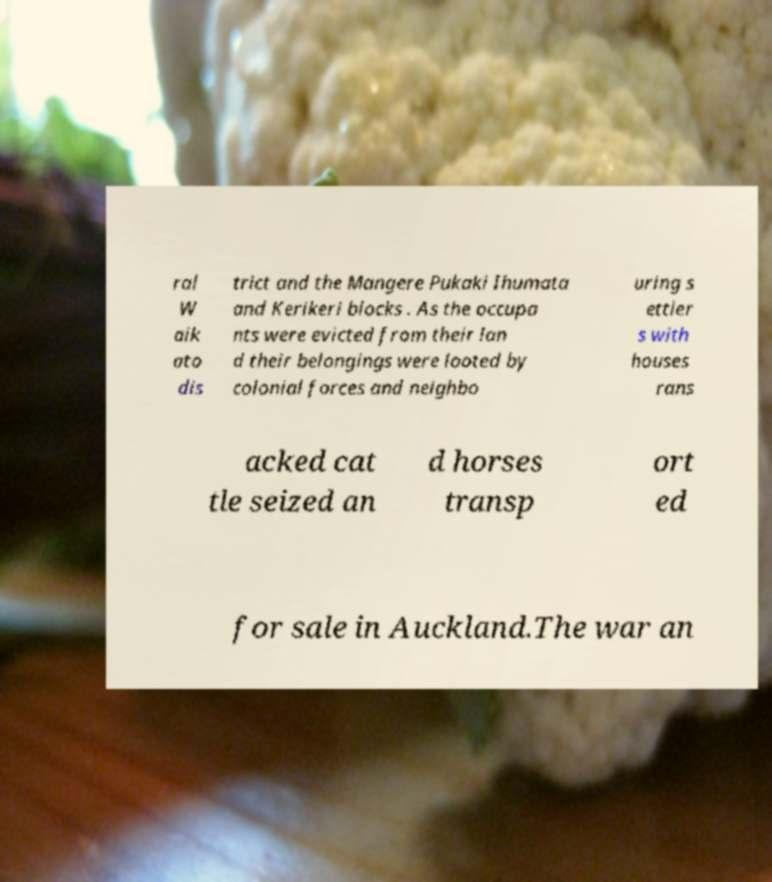Please read and relay the text visible in this image. What does it say? ral W aik ato dis trict and the Mangere Pukaki Ihumata and Kerikeri blocks . As the occupa nts were evicted from their lan d their belongings were looted by colonial forces and neighbo uring s ettler s with houses rans acked cat tle seized an d horses transp ort ed for sale in Auckland.The war an 